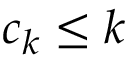<formula> <loc_0><loc_0><loc_500><loc_500>c _ { k } \leq k</formula> 